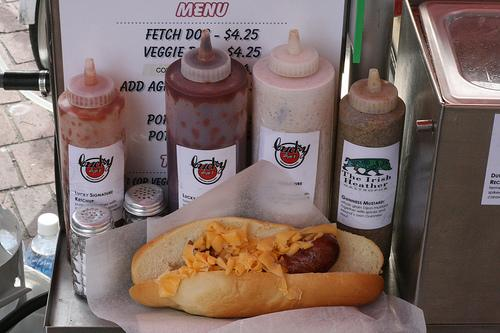What is noteworthy about the containment and surface the food items are on in the image? The hot dog is sitting on a white paper wrapper and a metal food storage bin is present next to some condiment bottles. Provide a description focused on the food items in the picture. The image presents a cheese-covered sausage in a burger bun that looks slightly burnt, accompanied by various condiments and salt and pepper shakers. Mention some items surrounding the hot dog in the image. There are salt and pepper shakers, bottles of ketchup, mustard, and white sauce, as well as a water bottle in the background. Provide a brief overview of the items present in the image. The image features a hot dog with cheese, a bun, salt and pepper shakers, various condiment bottles, a metal food storage bin, a water bottle, and a white menu sign. What is the setting of the picture and the time of day it was taken? The picture was taken outdoors, during the day, with a white menu sign against a window in the background. Describe the overall atmosphere and setting of the image, mentioning the key elements. The image has an outdoor daytime setting, displaying a delicious and slightly burnt hot dog with cheese and diverse condiments, creating a tempting and appetizing scene. Describe the appearance of the hot dog in the image. The hot dog is slightly burnt, covered with orange shredded cheese, and placed in a white and yellow bun, sitting on a white paper wrapper. Identify the types of seasoning that can be seen in the image. The image shows salt and pepper shakers, as well as sauces like ketchup, mustard, red sauce, white sauce (ranch), and green mustard. What condiments are visible in the image, and provide details about their appearance. There are bottles of ketchup, mustard, white sauce (ranch), green mustard, and red sauce. Some of the bottles are open, with white and green labels. Write a sentence describing the main course in the image and its accompaniments. A hot dog with cheese on a bun is featured, with salt and pepper shakers, and a variety of sauces in squeeze bottles nearby. 